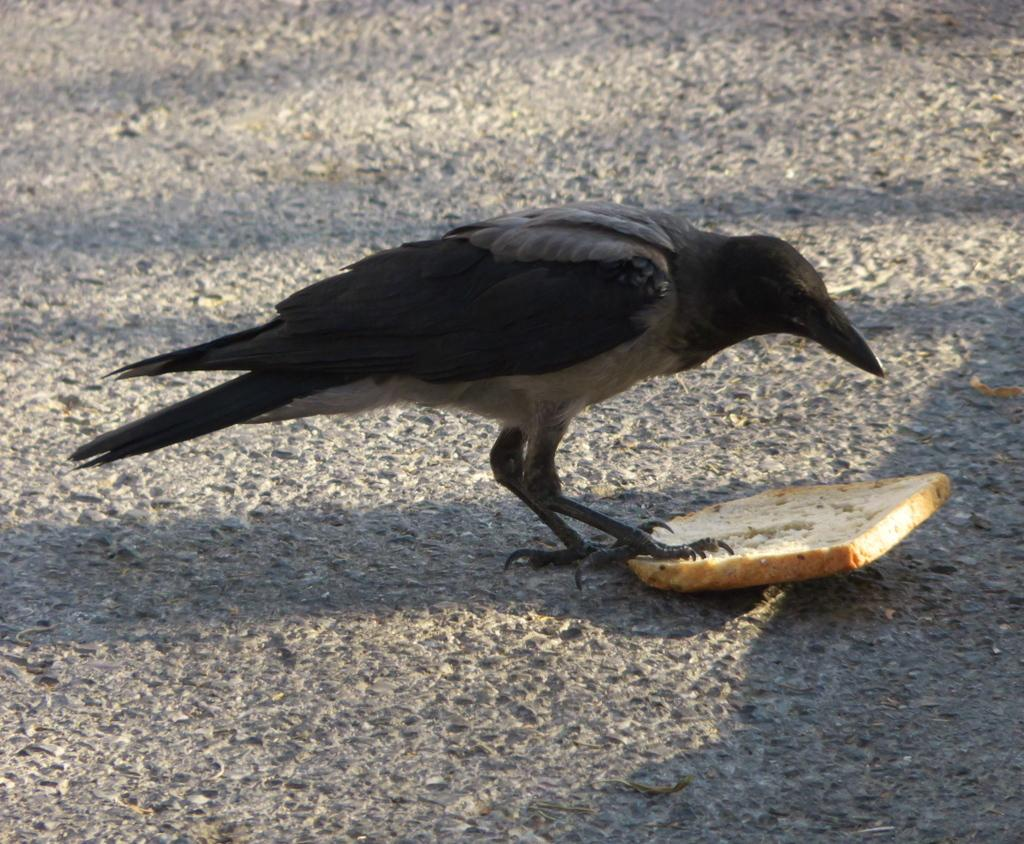What type of animal can be seen in the image? There is a bird in the image. What is the bird interacting with in the image? There is bread in the image, and the bird and bread are on the road. What fact can be learned about the country from the image? The image does not provide any information about a country, so no fact can be learned about a country from the image. 